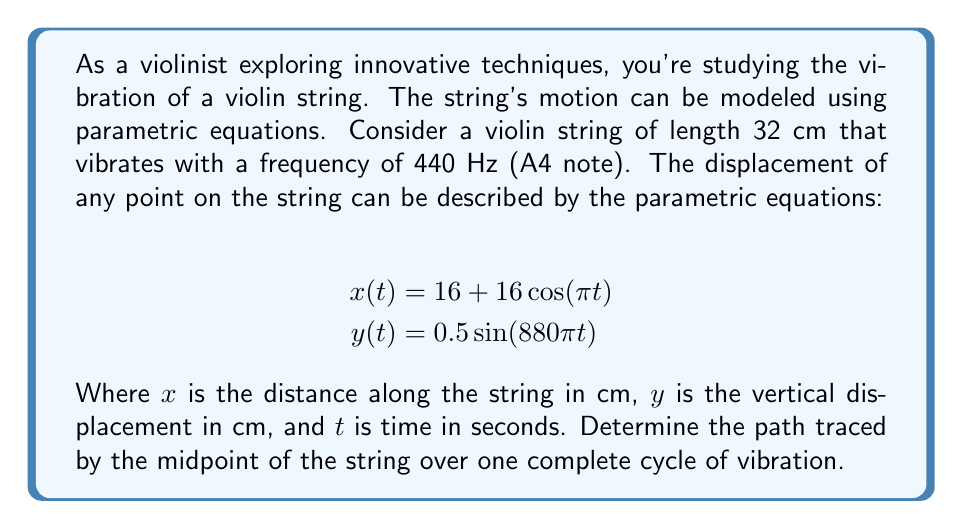Provide a solution to this math problem. Let's approach this step-by-step:

1) First, we need to understand what these equations represent:
   - $x(t)$ gives the position along the string
   - $y(t)$ gives the vertical displacement of the string

2) The midpoint of the string is at $x = 16$ cm (half of 32 cm).

3) To find when $x(t) = 16$, we solve:
   $$16 = 16 + 16\cos(\pi t)$$
   $$0 = 16\cos(\pi t)$$
   $$\cos(\pi t) = 0$$

4) This occurs when $\pi t = \frac{\pi}{2}$ or $\frac{3\pi}{2}$, i.e., when $t = \frac{1}{2}$ or $\frac{3}{2}$.

5) One complete cycle of vibration occurs when $t$ goes from 0 to 2 (because $\cos(\pi t)$ has a period of 2).

6) So, the midpoint's motion is described by:
   $$x = 16$$ (constant)
   $$y = 0.5\sin(880\pi t)$$ for $0 \leq t \leq 2$

7) This represents a vertical line segment. The extremes occur when $\sin(880\pi t) = \pm 1$:
   $$y_{max} = 0.5 \cdot 1 = 0.5$$ cm
   $$y_{min} = 0.5 \cdot (-1) = -0.5$$ cm

Therefore, the midpoint of the string vibrates up and down along a vertical line segment from -0.5 cm to 0.5 cm, centered at the point (16, 0).
Answer: The midpoint of the string traces a vertical line segment from (16, -0.5) to (16, 0.5), with the coordinates in centimeters. 